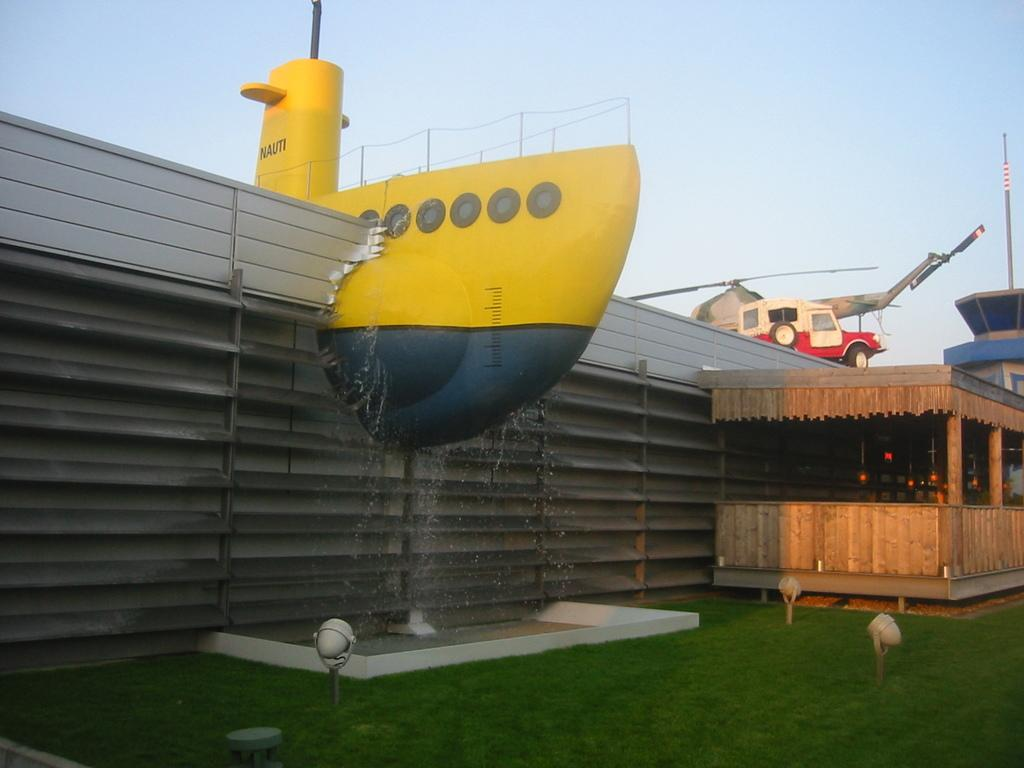What is the shape and color of the object on the wall in the image? The object on the wall is yellow and has a boat-like shape. What is the color of the sky in the image? The sky is blue in color. How much glue is needed to fix the boat-shaped object on the wall in the image? There is no information about glue or fixing the object in the image, so we cannot determine how much glue would be needed. What type of soup is being served in the image? There is no soup present in the image. 